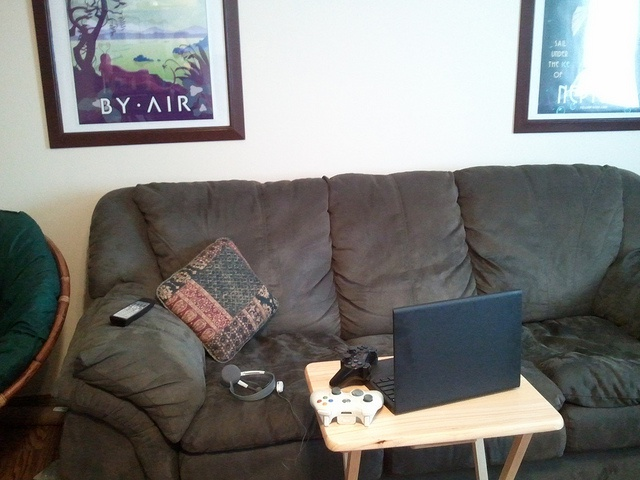Describe the objects in this image and their specific colors. I can see couch in darkgray, gray, and black tones, laptop in darkgray, darkblue, gray, and black tones, chair in darkgray, black, maroon, brown, and teal tones, remote in darkgray, ivory, tan, and gray tones, and remote in darkgray, black, and gray tones in this image. 